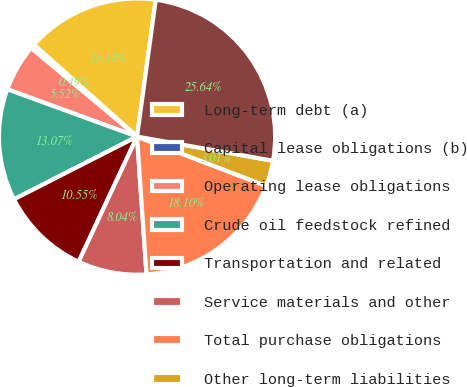<chart> <loc_0><loc_0><loc_500><loc_500><pie_chart><fcel>Long-term debt (a)<fcel>Capital lease obligations (b)<fcel>Operating lease obligations<fcel>Crude oil feedstock refined<fcel>Transportation and related<fcel>Service materials and other<fcel>Total purchase obligations<fcel>Other long-term liabilities<fcel>Total contractual cash<nl><fcel>15.58%<fcel>0.49%<fcel>5.52%<fcel>13.07%<fcel>10.55%<fcel>8.04%<fcel>18.1%<fcel>3.01%<fcel>25.64%<nl></chart> 